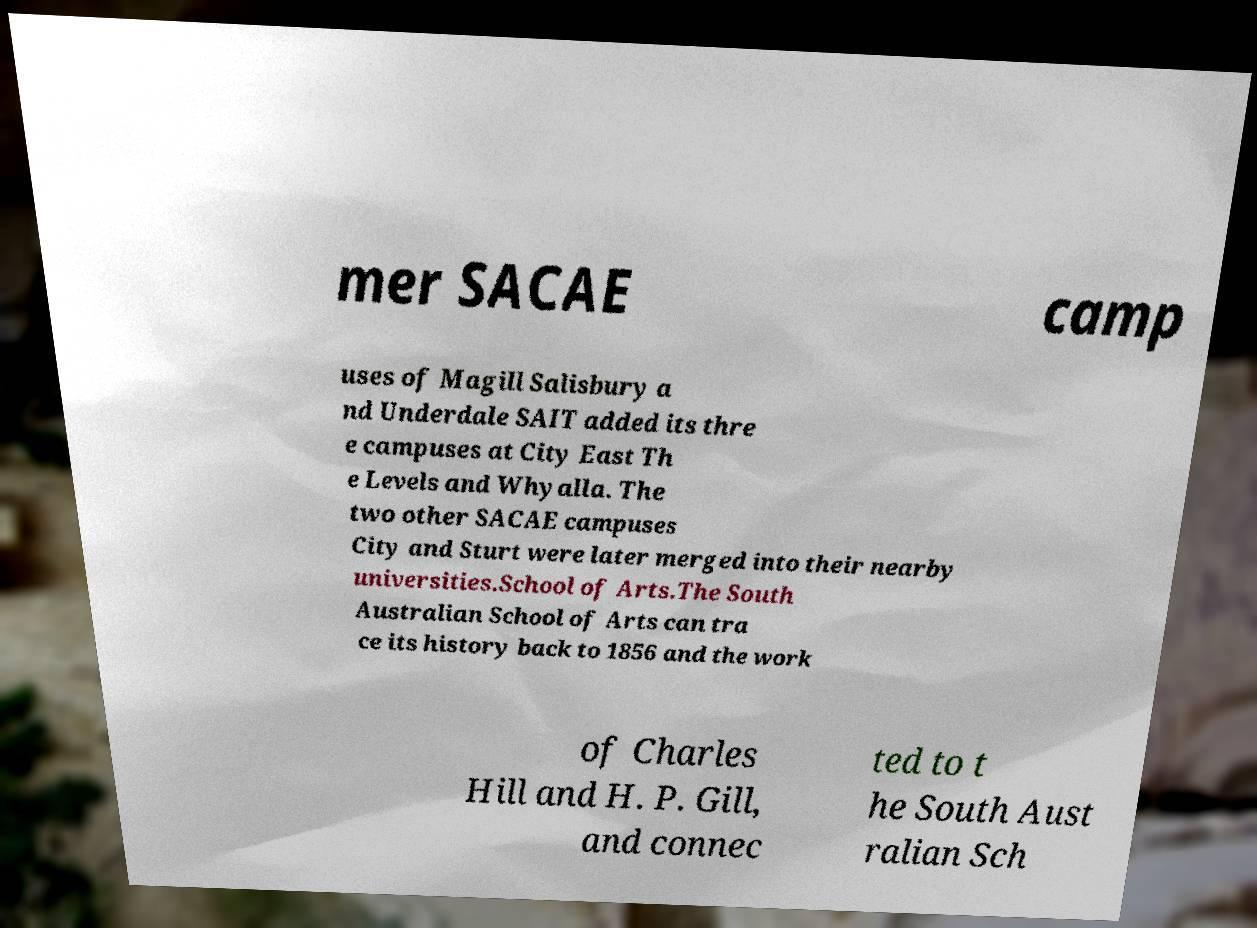There's text embedded in this image that I need extracted. Can you transcribe it verbatim? mer SACAE camp uses of Magill Salisbury a nd Underdale SAIT added its thre e campuses at City East Th e Levels and Whyalla. The two other SACAE campuses City and Sturt were later merged into their nearby universities.School of Arts.The South Australian School of Arts can tra ce its history back to 1856 and the work of Charles Hill and H. P. Gill, and connec ted to t he South Aust ralian Sch 